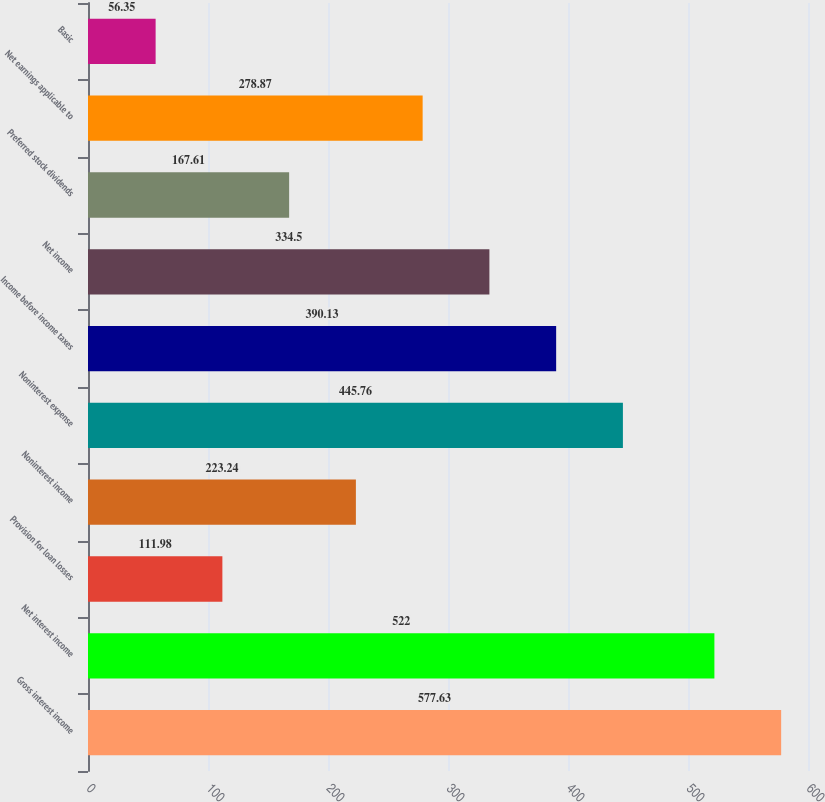Convert chart to OTSL. <chart><loc_0><loc_0><loc_500><loc_500><bar_chart><fcel>Gross interest income<fcel>Net interest income<fcel>Provision for loan losses<fcel>Noninterest income<fcel>Noninterest expense<fcel>Income before income taxes<fcel>Net income<fcel>Preferred stock dividends<fcel>Net earnings applicable to<fcel>Basic<nl><fcel>577.63<fcel>522<fcel>111.98<fcel>223.24<fcel>445.76<fcel>390.13<fcel>334.5<fcel>167.61<fcel>278.87<fcel>56.35<nl></chart> 